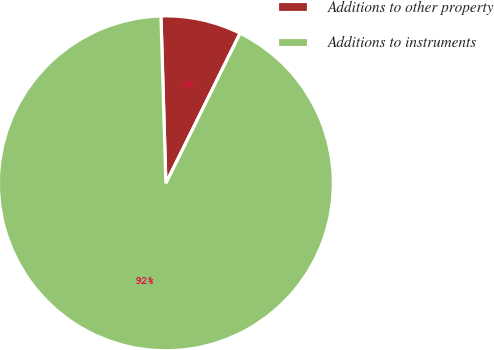Convert chart. <chart><loc_0><loc_0><loc_500><loc_500><pie_chart><fcel>Additions to other property<fcel>Additions to instruments<nl><fcel>7.78%<fcel>92.22%<nl></chart> 